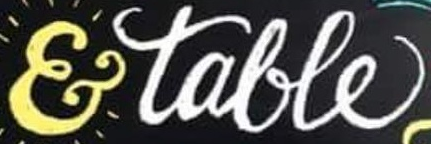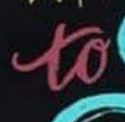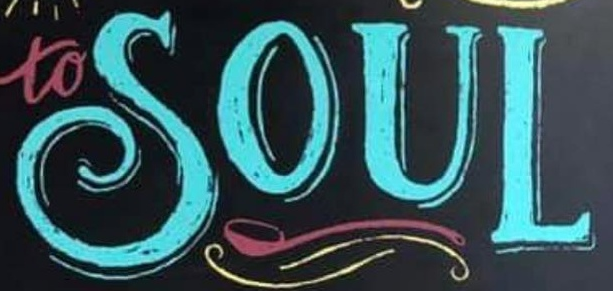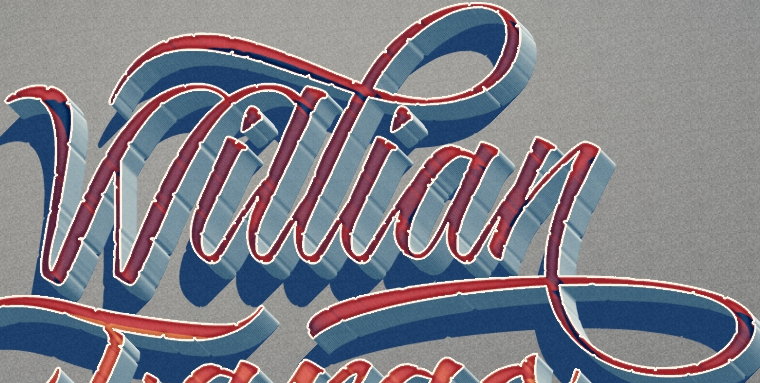Read the text content from these images in order, separated by a semicolon. &talle; to; SOUL; Willian 